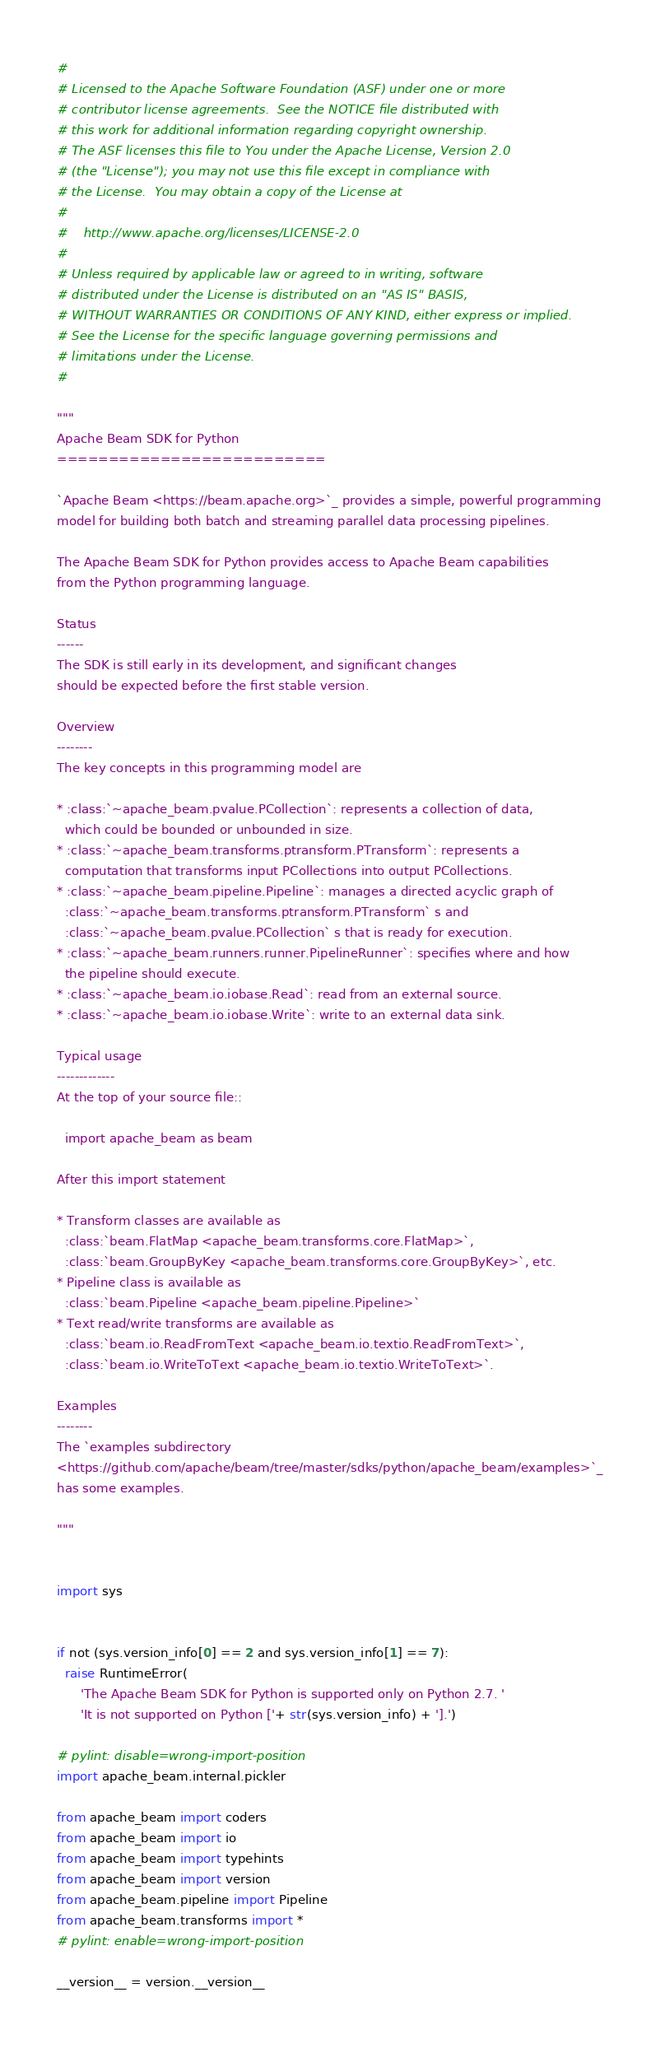<code> <loc_0><loc_0><loc_500><loc_500><_Python_>#
# Licensed to the Apache Software Foundation (ASF) under one or more
# contributor license agreements.  See the NOTICE file distributed with
# this work for additional information regarding copyright ownership.
# The ASF licenses this file to You under the Apache License, Version 2.0
# (the "License"); you may not use this file except in compliance with
# the License.  You may obtain a copy of the License at
#
#    http://www.apache.org/licenses/LICENSE-2.0
#
# Unless required by applicable law or agreed to in writing, software
# distributed under the License is distributed on an "AS IS" BASIS,
# WITHOUT WARRANTIES OR CONDITIONS OF ANY KIND, either express or implied.
# See the License for the specific language governing permissions and
# limitations under the License.
#

"""
Apache Beam SDK for Python
==========================

`Apache Beam <https://beam.apache.org>`_ provides a simple, powerful programming
model for building both batch and streaming parallel data processing pipelines.

The Apache Beam SDK for Python provides access to Apache Beam capabilities
from the Python programming language.

Status
------
The SDK is still early in its development, and significant changes
should be expected before the first stable version.

Overview
--------
The key concepts in this programming model are

* :class:`~apache_beam.pvalue.PCollection`: represents a collection of data,
  which could be bounded or unbounded in size.
* :class:`~apache_beam.transforms.ptransform.PTransform`: represents a
  computation that transforms input PCollections into output PCollections.
* :class:`~apache_beam.pipeline.Pipeline`: manages a directed acyclic graph of
  :class:`~apache_beam.transforms.ptransform.PTransform` s and
  :class:`~apache_beam.pvalue.PCollection` s that is ready for execution.
* :class:`~apache_beam.runners.runner.PipelineRunner`: specifies where and how
  the pipeline should execute.
* :class:`~apache_beam.io.iobase.Read`: read from an external source.
* :class:`~apache_beam.io.iobase.Write`: write to an external data sink.

Typical usage
-------------
At the top of your source file::

  import apache_beam as beam

After this import statement

* Transform classes are available as
  :class:`beam.FlatMap <apache_beam.transforms.core.FlatMap>`,
  :class:`beam.GroupByKey <apache_beam.transforms.core.GroupByKey>`, etc.
* Pipeline class is available as
  :class:`beam.Pipeline <apache_beam.pipeline.Pipeline>`
* Text read/write transforms are available as
  :class:`beam.io.ReadFromText <apache_beam.io.textio.ReadFromText>`,
  :class:`beam.io.WriteToText <apache_beam.io.textio.WriteToText>`.

Examples
--------
The `examples subdirectory
<https://github.com/apache/beam/tree/master/sdks/python/apache_beam/examples>`_
has some examples.

"""


import sys


if not (sys.version_info[0] == 2 and sys.version_info[1] == 7):
  raise RuntimeError(
      'The Apache Beam SDK for Python is supported only on Python 2.7. '
      'It is not supported on Python ['+ str(sys.version_info) + '].')

# pylint: disable=wrong-import-position
import apache_beam.internal.pickler

from apache_beam import coders
from apache_beam import io
from apache_beam import typehints
from apache_beam import version
from apache_beam.pipeline import Pipeline
from apache_beam.transforms import *
# pylint: enable=wrong-import-position

__version__ = version.__version__
</code> 